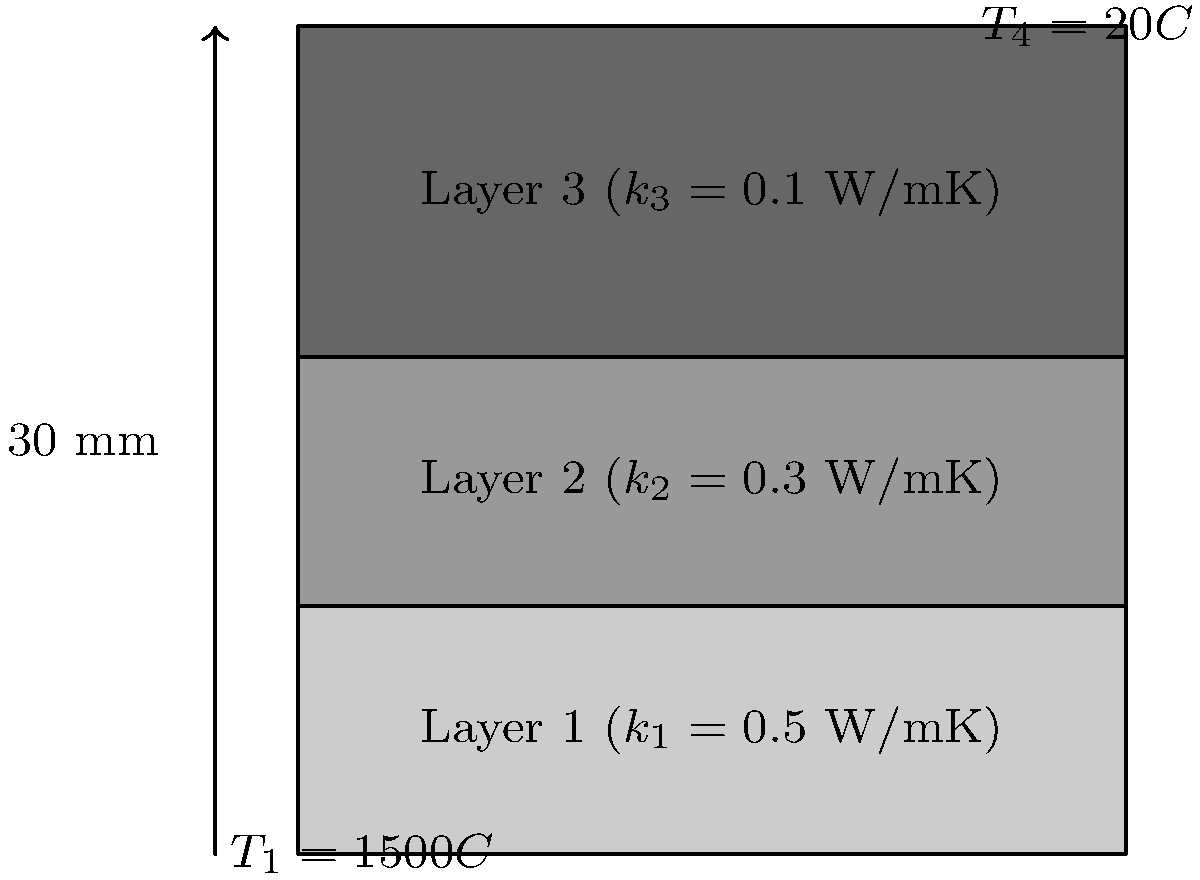A multi-layer heat shield for a Mars lander consists of three layers with different thermal conductivities ($k$) and a total thickness of 30 mm. Given the temperature at the outer surface ($T_1$) is 1500°C and the temperature at the inner surface ($T_4$) is 20°C, calculate the heat transfer rate per unit area through the heat shield. To solve this problem, we'll use Fourier's law of heat conduction and the concept of thermal resistance in series. Here's a step-by-step approach:

1) The heat transfer rate per unit area (q) is constant through all layers and can be expressed as:

   $q = \frac{T_1 - T_4}{R_{total}}$

   where $R_{total}$ is the total thermal resistance.

2) For conduction through a plane wall, the thermal resistance is given by:

   $R = \frac{L}{k}$

   where L is the thickness and k is the thermal conductivity.

3) The total resistance is the sum of individual layer resistances:

   $R_{total} = R_1 + R_2 + R_3 = \frac{L_1}{k_1} + \frac{L_2}{k_2} + \frac{L_3}{k_3}$

4) Given:
   - Total thickness = 30 mm = 0.03 m
   - Each layer thickness = 10 mm = 0.01 m
   - $k_1 = 0.5$ W/mK, $k_2 = 0.3$ W/mK, $k_3 = 0.1$ W/mK
   - $T_1 = 1500°C$, $T_4 = 20°C$

5) Calculate total thermal resistance:

   $R_{total} = \frac{0.01}{0.5} + \frac{0.01}{0.3} + \frac{0.01}{0.1} = 0.02 + 0.0333 + 0.1 = 0.1533$ m²K/W

6) Calculate heat transfer rate per unit area:

   $q = \frac{T_1 - T_4}{R_{total}} = \frac{1500 - 20}{0.1533} = 9653.6$ W/m²

Therefore, the heat transfer rate per unit area through the heat shield is approximately 9654 W/m².
Answer: 9654 W/m² 